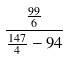Convert formula to latex. <formula><loc_0><loc_0><loc_500><loc_500>\frac { \frac { 9 9 } { 6 } } { \frac { 1 4 7 } { 4 } - 9 4 }</formula> 